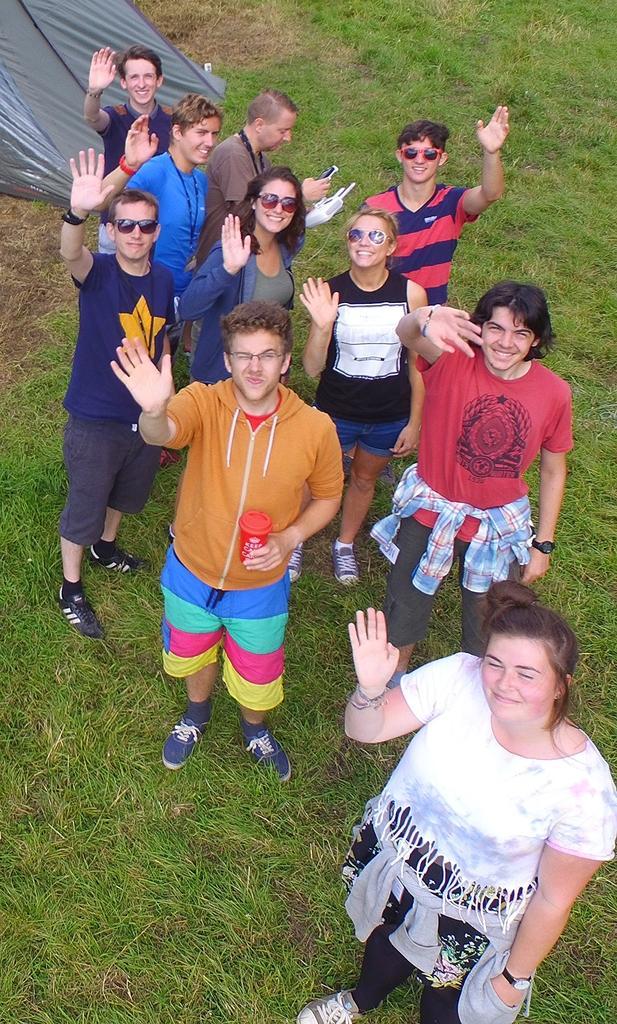In one or two sentences, can you explain what this image depicts? In this image, we can see a group of people are standing on the grass. Here we can see few people are smiling. On the left side top corner, there is a tent. 